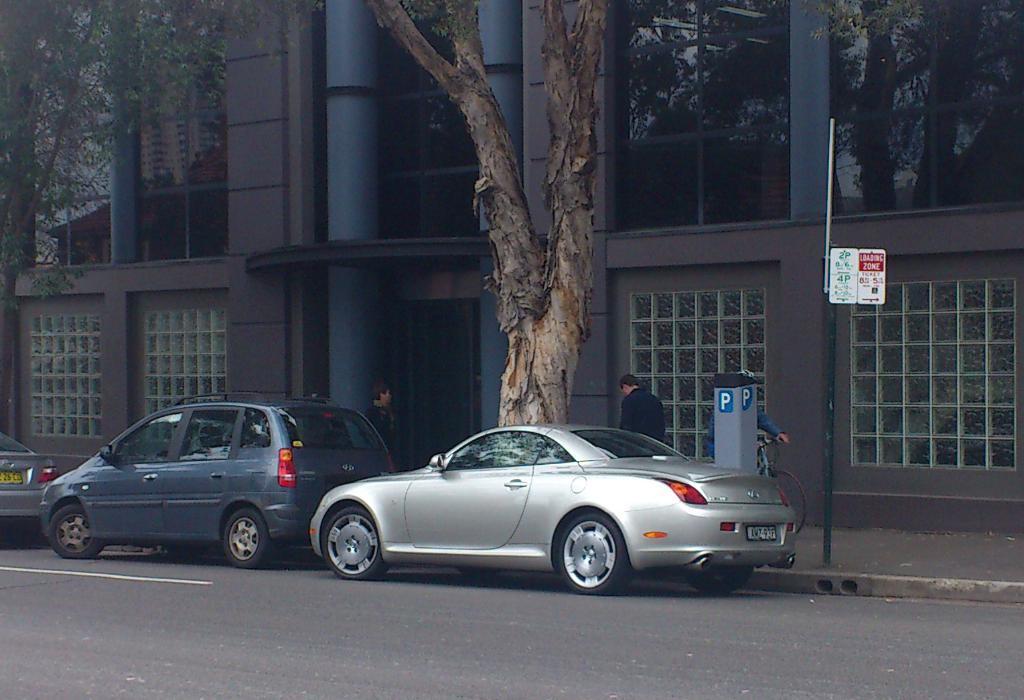In one or two sentences, can you explain what this image depicts? In this image there are a few vehicles on the road, behind that there are a few people walking on the pavement and a person riding a bicycle, there is a pole and an object. In the background there is a building and trees. 